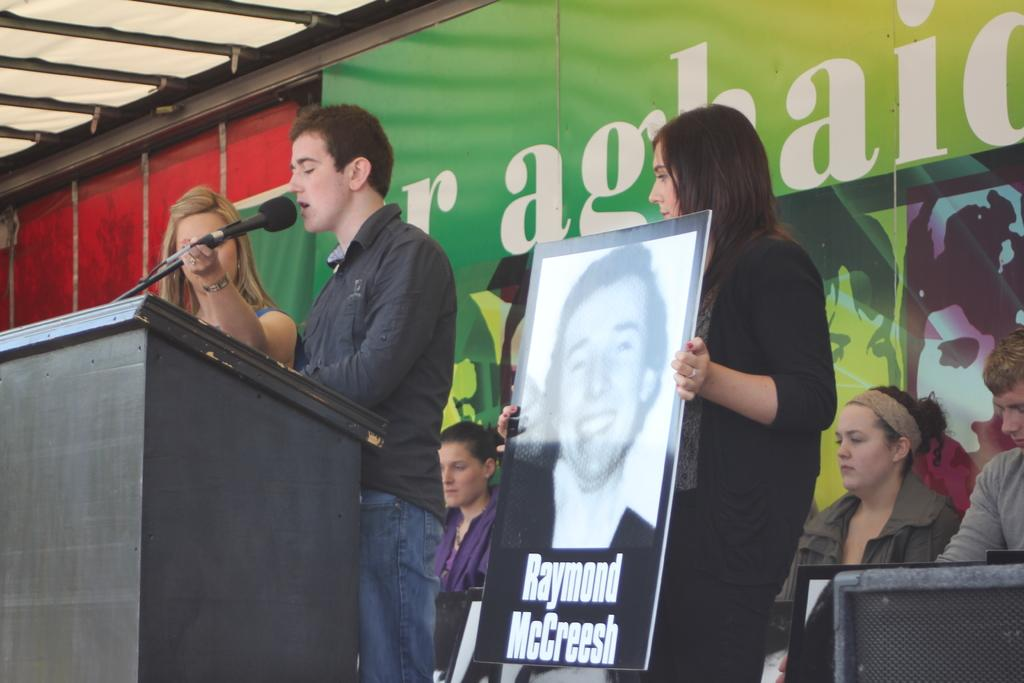How many people are in the image? There is a group of people in the image. What is the woman holding in the image? The woman is holding a poster. What object is typically used for amplifying sound and is present in the image? A microphone is present in the image. What can be seen in the background of the image? There is a banner in the background of the image. What type of instrument is the woman playing in the image? There is no instrument present in the image, and the woman is holding a poster, not playing an instrument. How many thumbs does the woman have on her right hand in the image? The image does not provide enough detail to determine the number of thumbs on the woman's right hand. 